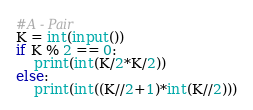<code> <loc_0><loc_0><loc_500><loc_500><_Python_>#A - Pair
K = int(input())
if K % 2 == 0:
    print(int(K/2*K/2))
else:
    print(int((K//2+1)*int(K//2)))</code> 